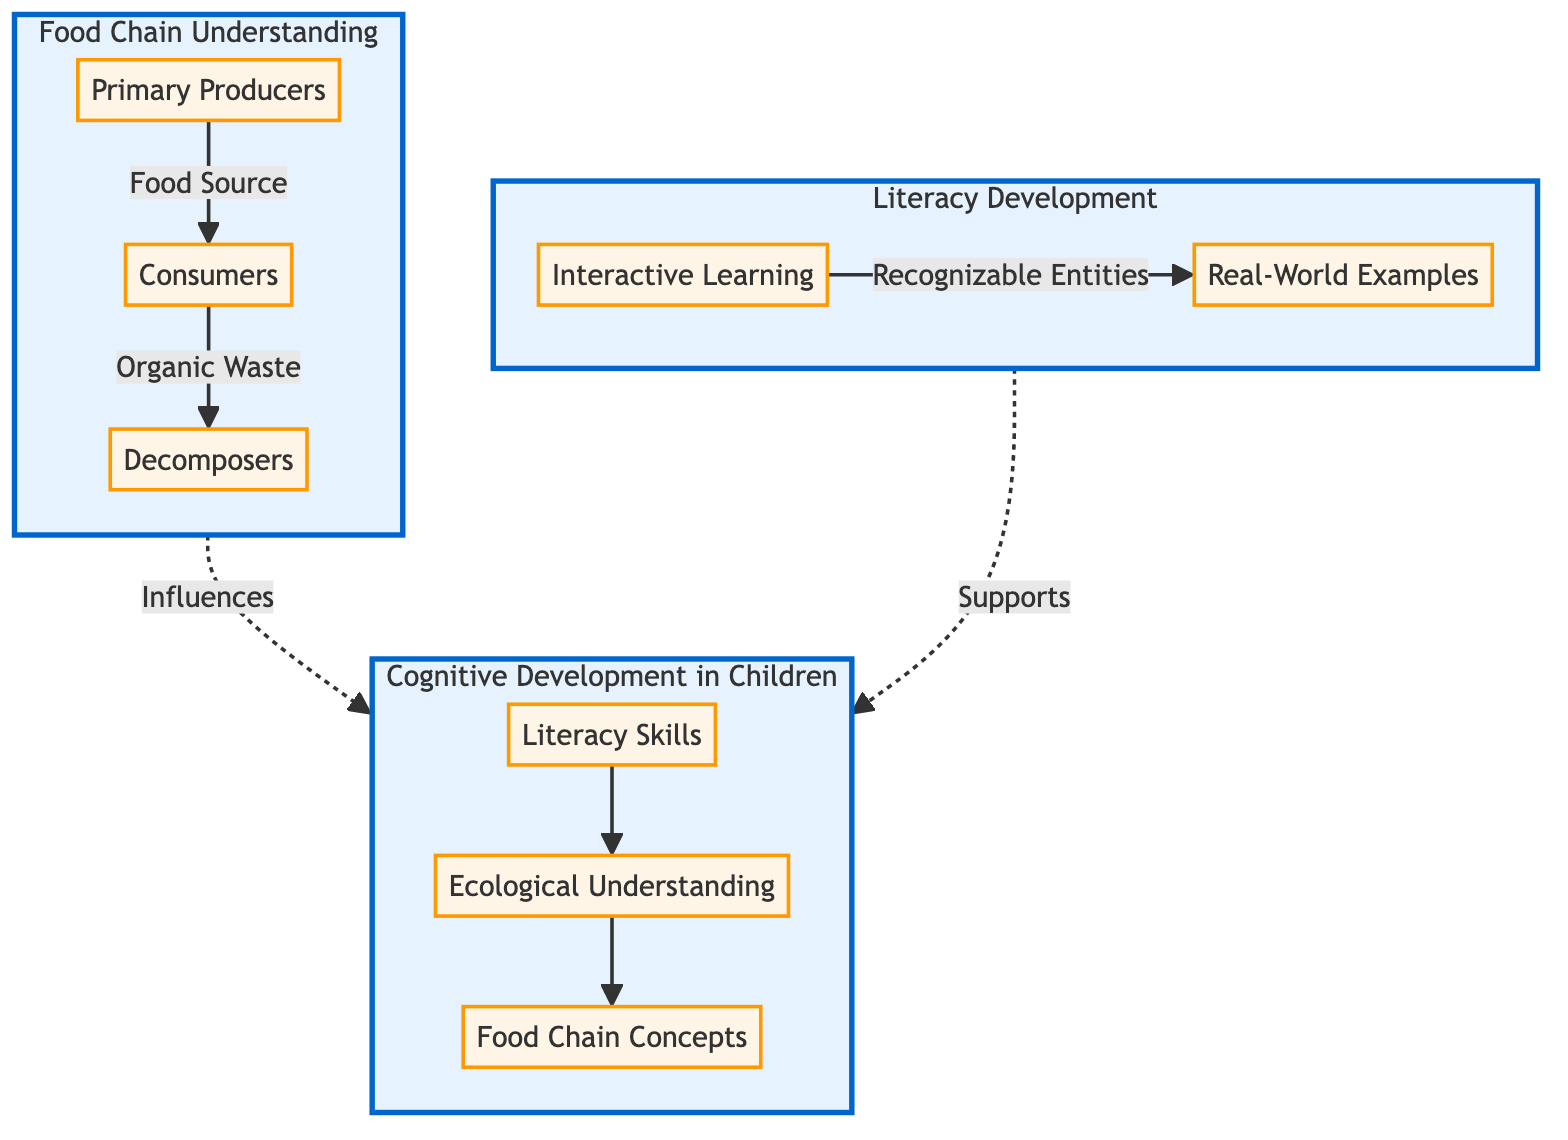What are the three main components of the food chain represented in the diagram? The diagram lists the components as Primary Producers, Consumers, and Decomposers, which are clearly labeled in the "Food Chain Understanding" subsection.
Answer: Primary Producers, Consumers, Decomposers How many supporting nodes are in the "Cognitive Development in Children" subgraph? The subgraph contains three supporting nodes: Literacy Skills, Ecological Understanding, and Food Chain Concepts, which can be counted directly from the diagram.
Answer: 3 Which node influences Cognitive Development according to the flow of the diagram? The flow indicates that both the Food Chain and Literacy subgraphs influence Cognitive Development, as represented by the dashed arrows connecting them.
Answer: Food Chain, Literacy What is the relationship between Interactive Learning and Real-World Examples? The diagram illustrates a directional relationship where Interactive Learning leads to Real-World Examples, indicating that understanding is built through interaction.
Answer: Recognizable Entities How many arrows point into the Decomposers node in the diagram? There is one arrow pointing into the Decomposers node, indicating that it receives organic waste from the Consumers node.
Answer: 1 What is the main educational focus highlighted in the diagram? The diagram highlights the integration of literacy development with ecological understanding, as shown through the connections between the nodes.
Answer: Literacy Development How do Primary Producers relate to Consumers in the diagram? The diagram shows a direct relationship from Primary Producers to Consumers through an arrow labeled "Food Source," indicating that Primary Producers provide food for Consumers.
Answer: Food Source Which aspect of cognitive development is represented as a result of literacy skills in the diagram? The diagram details that Literacy Skills lead to Ecological Understanding, which subsequently contributes to understanding of Food Chain Concepts in children.
Answer: Ecological Understanding 